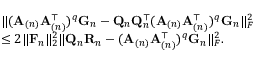Convert formula to latex. <formula><loc_0><loc_0><loc_500><loc_500>\begin{array} { r l } & { \| ( A _ { ( n ) } A _ { ( n ) } ^ { \top } ) ^ { q } G _ { n } - Q _ { n } Q _ { n } ^ { \top } ( A _ { ( n ) } A _ { ( n ) } ^ { \top } ) ^ { q } G _ { n } \| _ { F } ^ { 2 } } \\ & { \leq 2 \| F _ { n } \| _ { 2 } ^ { 2 } \| Q _ { n } R _ { n } - ( A _ { ( n ) } A _ { ( n ) } ^ { \top } ) ^ { q } G _ { n } \| _ { F } ^ { 2 } . } \end{array}</formula> 